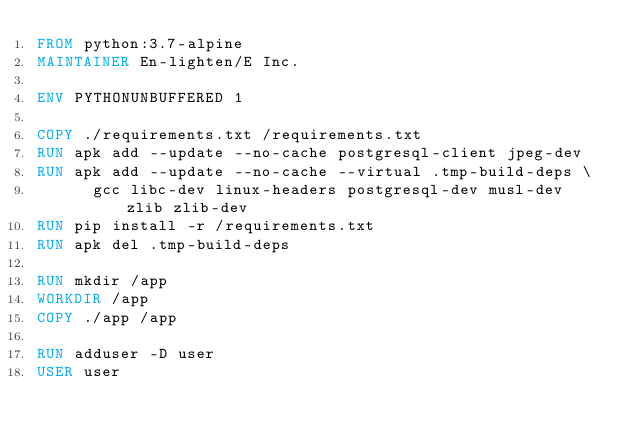<code> <loc_0><loc_0><loc_500><loc_500><_Dockerfile_>FROM python:3.7-alpine
MAINTAINER En-lighten/E Inc.

ENV PYTHONUNBUFFERED 1

COPY ./requirements.txt /requirements.txt
RUN apk add --update --no-cache postgresql-client jpeg-dev
RUN apk add --update --no-cache --virtual .tmp-build-deps \
      gcc libc-dev linux-headers postgresql-dev musl-dev zlib zlib-dev 
RUN pip install -r /requirements.txt
RUN apk del .tmp-build-deps

RUN mkdir /app
WORKDIR /app
COPY ./app /app

RUN adduser -D user
USER user
</code> 